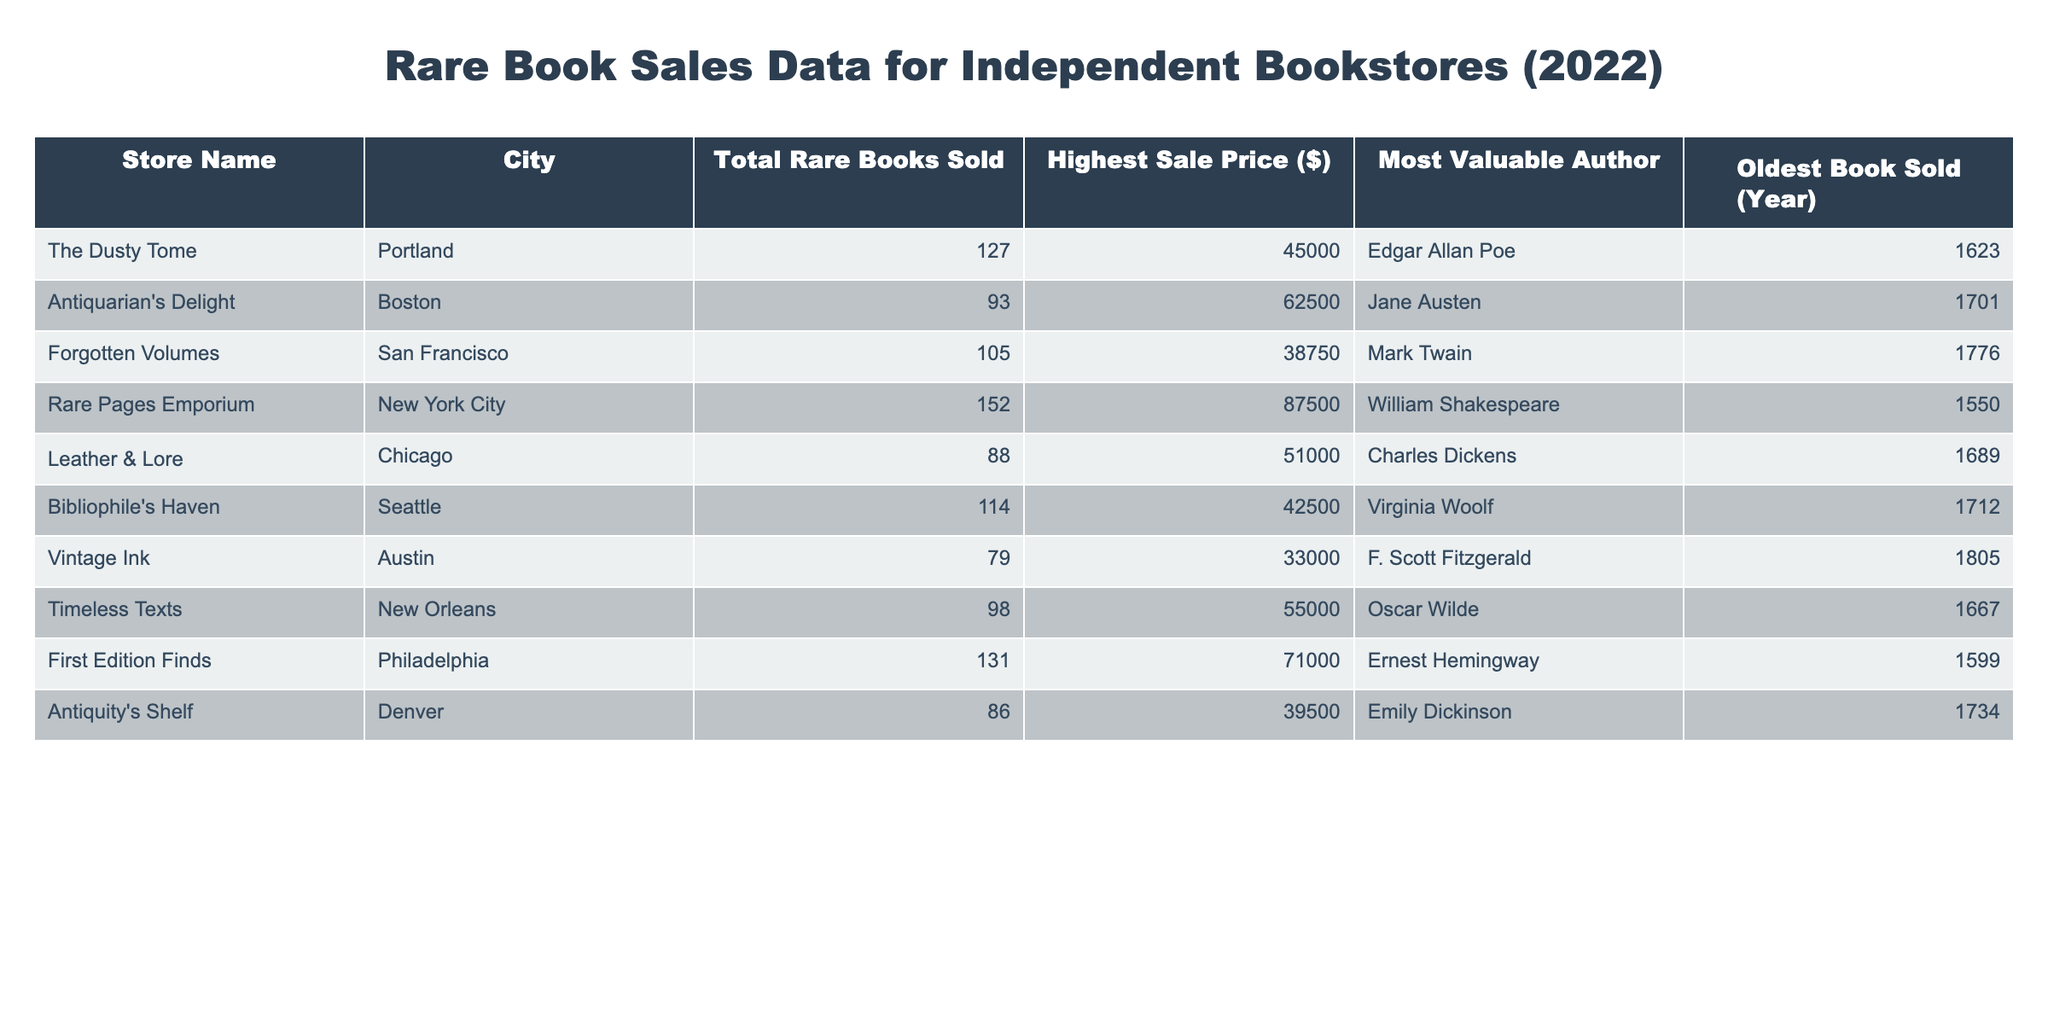What is the total number of rare books sold by 'Rare Pages Emporium'? The table lists the 'Total Rare Books Sold' for each store, and for 'Rare Pages Emporium,' this value is 152.
Answer: 152 Which bookstore has the highest sale price for a rare book? Looking under the 'Highest Sale Price ($)' column, 'Rare Pages Emporium' shows the highest value at 87500$.
Answer: Rare Pages Emporium What is the average highest sale price of rare books across all bookstores? Summing the highest sale prices (45000 + 62500 + 38750 + 87500 + 51000 + 42500 + 33000 + 55000 + 71000 + 39500) gives 500000. This total divided by 10 bookstores yields an average of 50000.
Answer: 50000 Which city had the least books sold, and how many were sold? By comparing the 'Total Rare Books Sold' column, 'Vintage Ink' in Austin has the least sales with 79.
Answer: Austin, 79 Is the 'Most Valuable Author' at 'The Dusty Tome' older than the oldest book sold by 'Forgotten Volumes'? 'The Dusty Tome' has Edgar Allan Poe, whose oldest book sold is from 1623, and 'Forgotten Volumes' lists Mark Twain with the oldest book from 1776. Since 1623 is earlier than 1776, the answer is yes.
Answer: Yes What is the difference between the total rare books sold by 'First Edition Finds' and 'Antiquity's Shelf'? 'First Edition Finds' sold 131 rare books and 'Antiquity's Shelf' sold 86 books. Subtracting gives 131 - 86 = 45.
Answer: 45 Which author had the oldest book sold across all bookstores? The 'Oldest Book Sold (Year)' column shows the earliest year is 1550 from 'Rare Pages Emporium' with William Shakespeare as the author.
Answer: William Shakespeare How many bookstores sold more than 100 rare books? By counting the entries in the 'Total Rare Books Sold' column, four bookstores reported sales exceeding 100: 'Rare Pages Emporium,' 'First Edition Finds,' 'The Dusty Tome,' and 'Forgotten Volumes.'
Answer: 4 Which city had the highest average of rare books sold? Listing the total rare books sold by city: Portland (127), Boston (93), San Francisco (105), New York City (152), Chicago (88), Seattle (114), Austin (79), New Orleans (98), Philadelphia (131), and Denver (86). The average for New York City is the highest at 152.
Answer: New York City If we only consider the two bookstores from Boston and Philadelphia, which had the higher price for their most valuable book? 'Antiquarian's Delight' from Boston has a highest sale price of 62500$, while 'First Edition Finds' from Philadelphia has 71000$. Since 71000 is higher, Philadelphia has the higher price.
Answer: Philadelphia How many of the bookstores sold more than 90 rare books and had a highest sale price of at least 50000$? Checking the data, 'Rare Pages Emporium,' 'First Edition Finds,' and 'Timeless Texts' fit this criteria. Therefore, there are three bookstores that meet both conditions.
Answer: 3 